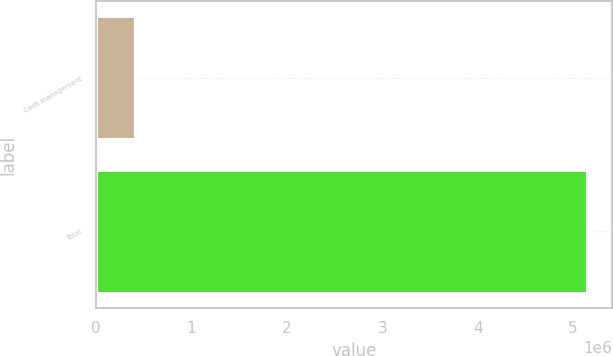Convert chart. <chart><loc_0><loc_0><loc_500><loc_500><bar_chart><fcel>Cash management<fcel>Total<nl><fcel>403584<fcel>5.14785e+06<nl></chart> 